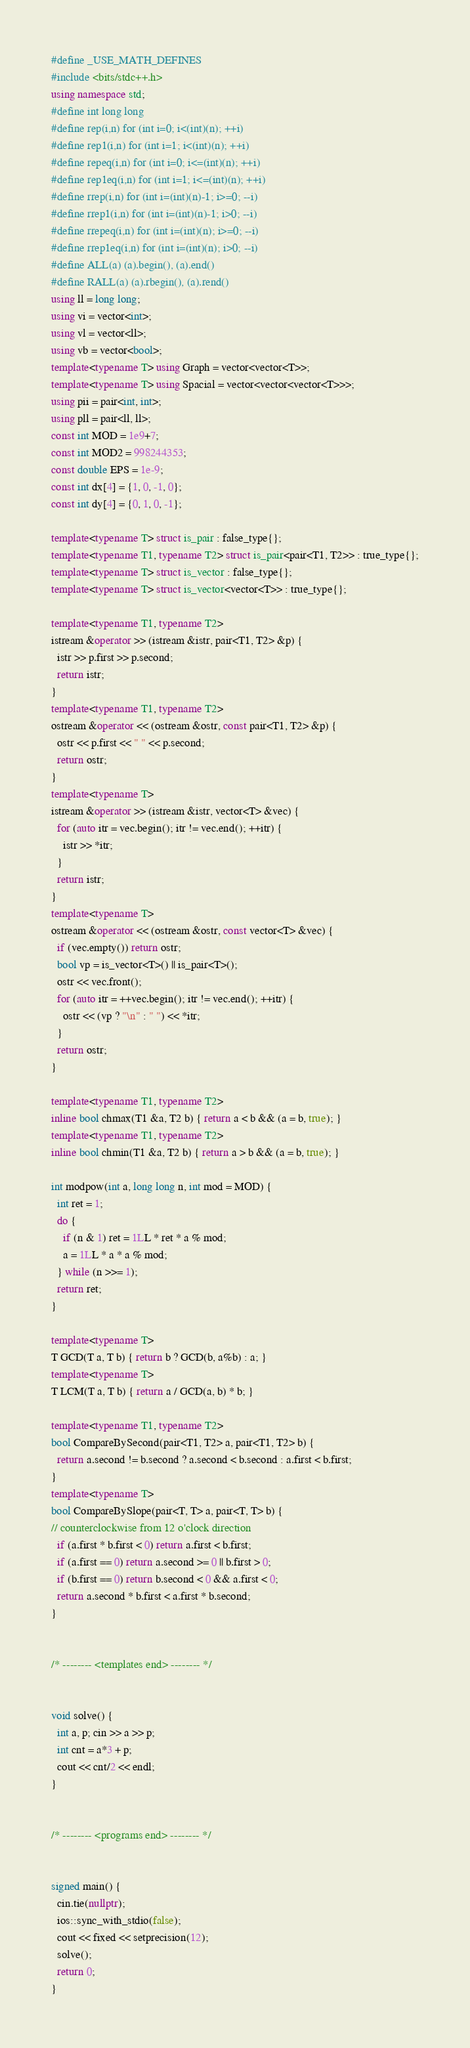Convert code to text. <code><loc_0><loc_0><loc_500><loc_500><_C++_>#define _USE_MATH_DEFINES
#include <bits/stdc++.h>
using namespace std;
#define int long long
#define rep(i,n) for (int i=0; i<(int)(n); ++i)
#define rep1(i,n) for (int i=1; i<(int)(n); ++i)
#define repeq(i,n) for (int i=0; i<=(int)(n); ++i)
#define rep1eq(i,n) for (int i=1; i<=(int)(n); ++i)
#define rrep(i,n) for (int i=(int)(n)-1; i>=0; --i)
#define rrep1(i,n) for (int i=(int)(n)-1; i>0; --i)
#define rrepeq(i,n) for (int i=(int)(n); i>=0; --i)
#define rrep1eq(i,n) for (int i=(int)(n); i>0; --i)
#define ALL(a) (a).begin(), (a).end()
#define RALL(a) (a).rbegin(), (a).rend()
using ll = long long;
using vi = vector<int>;
using vl = vector<ll>;
using vb = vector<bool>;
template<typename T> using Graph = vector<vector<T>>;
template<typename T> using Spacial = vector<vector<vector<T>>>;
using pii = pair<int, int>;
using pll = pair<ll, ll>;
const int MOD = 1e9+7;
const int MOD2 = 998244353;
const double EPS = 1e-9;
const int dx[4] = {1, 0, -1, 0};
const int dy[4] = {0, 1, 0, -1};

template<typename T> struct is_pair : false_type{};
template<typename T1, typename T2> struct is_pair<pair<T1, T2>> : true_type{};
template<typename T> struct is_vector : false_type{};
template<typename T> struct is_vector<vector<T>> : true_type{};

template<typename T1, typename T2>
istream &operator >> (istream &istr, pair<T1, T2> &p) {
  istr >> p.first >> p.second;
  return istr;
} 
template<typename T1, typename T2>
ostream &operator << (ostream &ostr, const pair<T1, T2> &p) {
  ostr << p.first << " " << p.second;
  return ostr;
}
template<typename T>
istream &operator >> (istream &istr, vector<T> &vec) {
  for (auto itr = vec.begin(); itr != vec.end(); ++itr) {
    istr >> *itr;
  }
  return istr;
}
template<typename T>
ostream &operator << (ostream &ostr, const vector<T> &vec) {
  if (vec.empty()) return ostr;
  bool vp = is_vector<T>() || is_pair<T>();
  ostr << vec.front();
  for (auto itr = ++vec.begin(); itr != vec.end(); ++itr) {
    ostr << (vp ? "\n" : " ") << *itr;
  }
  return ostr;
}

template<typename T1, typename T2>
inline bool chmax(T1 &a, T2 b) { return a < b && (a = b, true); }
template<typename T1, typename T2>
inline bool chmin(T1 &a, T2 b) { return a > b && (a = b, true); }

int modpow(int a, long long n, int mod = MOD) {
  int ret = 1;
  do {
    if (n & 1) ret = 1LL * ret * a % mod;
    a = 1LL * a * a % mod;
  } while (n >>= 1);
  return ret;
}

template<typename T>
T GCD(T a, T b) { return b ? GCD(b, a%b) : a; }
template<typename T>
T LCM(T a, T b) { return a / GCD(a, b) * b; }

template<typename T1, typename T2>
bool CompareBySecond(pair<T1, T2> a, pair<T1, T2> b) {
  return a.second != b.second ? a.second < b.second : a.first < b.first;
}
template<typename T>
bool CompareBySlope(pair<T, T> a, pair<T, T> b) {
// counterclockwise from 12 o'clock direction
  if (a.first * b.first < 0) return a.first < b.first;
  if (a.first == 0) return a.second >= 0 || b.first > 0;
  if (b.first == 0) return b.second < 0 && a.first < 0;
  return a.second * b.first < a.first * b.second;
}


/* -------- <templates end> -------- */


void solve() {
  int a, p; cin >> a >> p;
  int cnt = a*3 + p;
  cout << cnt/2 << endl;
}


/* -------- <programs end> -------- */


signed main() {
  cin.tie(nullptr);
  ios::sync_with_stdio(false);
  cout << fixed << setprecision(12);
  solve();
  return 0;
}
</code> 